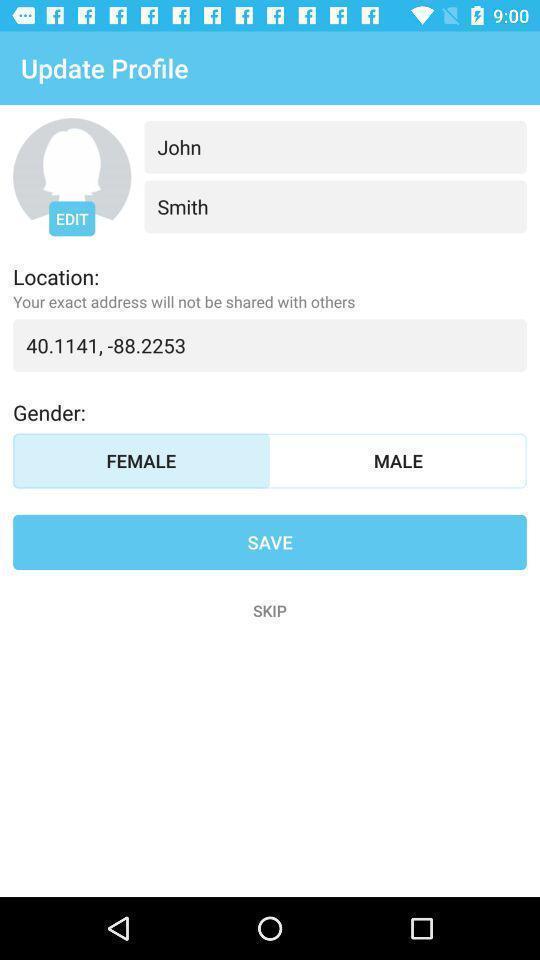Describe the key features of this screenshot. Screen shows an update for profile. 